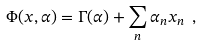Convert formula to latex. <formula><loc_0><loc_0><loc_500><loc_500>\Phi ( x , \alpha ) = \Gamma ( \alpha ) + \sum _ { n } \alpha _ { n } x _ { n } \ ,</formula> 